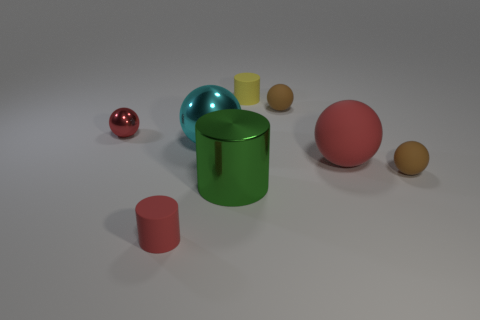Subtract all small yellow cylinders. How many cylinders are left? 2 Subtract all cyan spheres. How many spheres are left? 4 Subtract 1 cylinders. How many cylinders are left? 2 Subtract all cyan cylinders. Subtract all purple cubes. How many cylinders are left? 3 Add 1 red cubes. How many objects exist? 9 Subtract all spheres. How many objects are left? 3 Subtract all red matte things. Subtract all cyan metal things. How many objects are left? 5 Add 7 big spheres. How many big spheres are left? 9 Add 6 small cyan matte cylinders. How many small cyan matte cylinders exist? 6 Subtract 0 brown blocks. How many objects are left? 8 